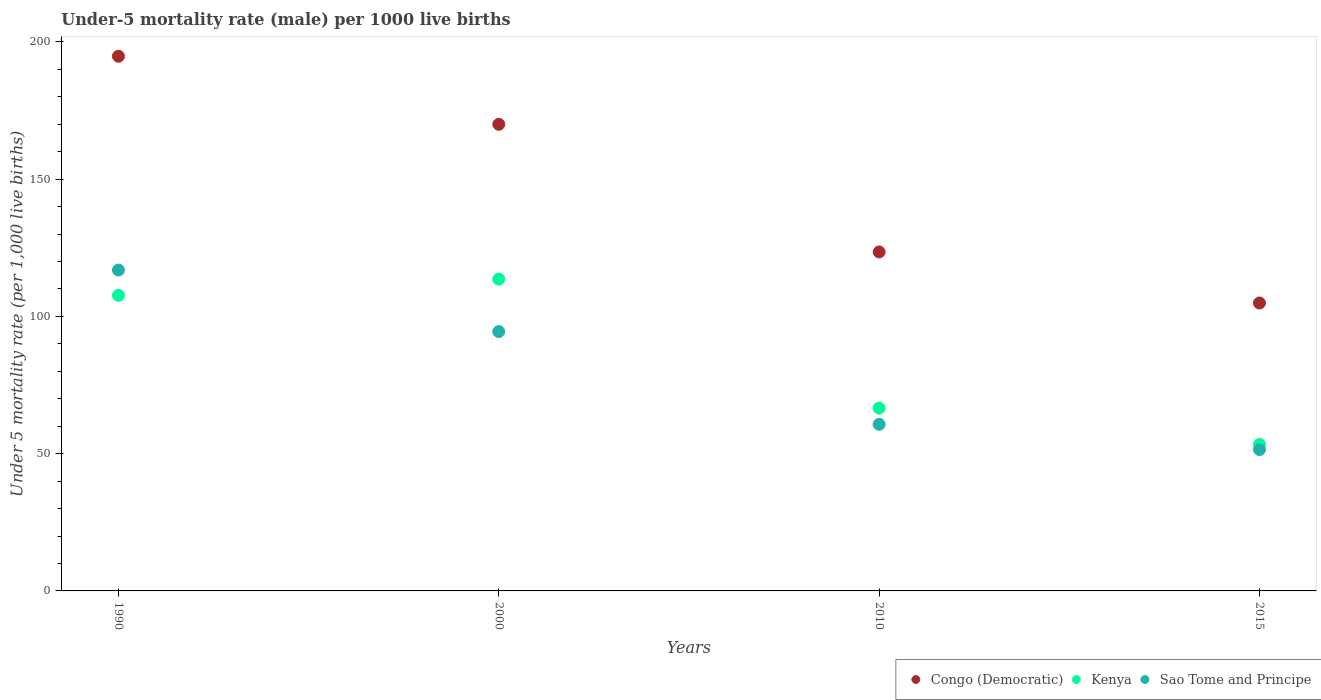How many different coloured dotlines are there?
Ensure brevity in your answer.  3. What is the under-five mortality rate in Kenya in 2000?
Offer a terse response. 113.6. Across all years, what is the maximum under-five mortality rate in Kenya?
Make the answer very short. 113.6. Across all years, what is the minimum under-five mortality rate in Sao Tome and Principe?
Your response must be concise. 51.5. In which year was the under-five mortality rate in Congo (Democratic) minimum?
Provide a succinct answer. 2015. What is the total under-five mortality rate in Kenya in the graph?
Give a very brief answer. 341.3. What is the difference between the under-five mortality rate in Kenya in 2000 and that in 2010?
Offer a terse response. 47. What is the difference between the under-five mortality rate in Sao Tome and Principe in 2015 and the under-five mortality rate in Congo (Democratic) in 2000?
Offer a terse response. -118.5. What is the average under-five mortality rate in Sao Tome and Principe per year?
Ensure brevity in your answer.  80.9. In the year 2010, what is the difference between the under-five mortality rate in Kenya and under-five mortality rate in Congo (Democratic)?
Offer a very short reply. -56.9. What is the ratio of the under-five mortality rate in Sao Tome and Principe in 2000 to that in 2010?
Your response must be concise. 1.56. Is the under-five mortality rate in Sao Tome and Principe in 2000 less than that in 2015?
Make the answer very short. No. What is the difference between the highest and the second highest under-five mortality rate in Sao Tome and Principe?
Your response must be concise. 22.4. What is the difference between the highest and the lowest under-five mortality rate in Congo (Democratic)?
Your answer should be very brief. 89.9. In how many years, is the under-five mortality rate in Congo (Democratic) greater than the average under-five mortality rate in Congo (Democratic) taken over all years?
Provide a succinct answer. 2. Is the sum of the under-five mortality rate in Congo (Democratic) in 1990 and 2010 greater than the maximum under-five mortality rate in Sao Tome and Principe across all years?
Make the answer very short. Yes. Does the under-five mortality rate in Sao Tome and Principe monotonically increase over the years?
Offer a terse response. No. Is the under-five mortality rate in Kenya strictly less than the under-five mortality rate in Congo (Democratic) over the years?
Make the answer very short. Yes. How many dotlines are there?
Ensure brevity in your answer.  3. Does the graph contain any zero values?
Offer a terse response. No. Does the graph contain grids?
Make the answer very short. No. How many legend labels are there?
Make the answer very short. 3. What is the title of the graph?
Give a very brief answer. Under-5 mortality rate (male) per 1000 live births. What is the label or title of the X-axis?
Your answer should be compact. Years. What is the label or title of the Y-axis?
Your response must be concise. Under 5 mortality rate (per 1,0 live births). What is the Under 5 mortality rate (per 1,000 live births) in Congo (Democratic) in 1990?
Provide a succinct answer. 194.8. What is the Under 5 mortality rate (per 1,000 live births) of Kenya in 1990?
Your response must be concise. 107.7. What is the Under 5 mortality rate (per 1,000 live births) of Sao Tome and Principe in 1990?
Provide a succinct answer. 116.9. What is the Under 5 mortality rate (per 1,000 live births) in Congo (Democratic) in 2000?
Your answer should be very brief. 170. What is the Under 5 mortality rate (per 1,000 live births) in Kenya in 2000?
Your response must be concise. 113.6. What is the Under 5 mortality rate (per 1,000 live births) in Sao Tome and Principe in 2000?
Keep it short and to the point. 94.5. What is the Under 5 mortality rate (per 1,000 live births) in Congo (Democratic) in 2010?
Your response must be concise. 123.5. What is the Under 5 mortality rate (per 1,000 live births) in Kenya in 2010?
Provide a short and direct response. 66.6. What is the Under 5 mortality rate (per 1,000 live births) in Sao Tome and Principe in 2010?
Your answer should be compact. 60.7. What is the Under 5 mortality rate (per 1,000 live births) of Congo (Democratic) in 2015?
Make the answer very short. 104.9. What is the Under 5 mortality rate (per 1,000 live births) in Kenya in 2015?
Offer a terse response. 53.4. What is the Under 5 mortality rate (per 1,000 live births) of Sao Tome and Principe in 2015?
Give a very brief answer. 51.5. Across all years, what is the maximum Under 5 mortality rate (per 1,000 live births) of Congo (Democratic)?
Offer a terse response. 194.8. Across all years, what is the maximum Under 5 mortality rate (per 1,000 live births) in Kenya?
Provide a succinct answer. 113.6. Across all years, what is the maximum Under 5 mortality rate (per 1,000 live births) in Sao Tome and Principe?
Offer a terse response. 116.9. Across all years, what is the minimum Under 5 mortality rate (per 1,000 live births) in Congo (Democratic)?
Your answer should be very brief. 104.9. Across all years, what is the minimum Under 5 mortality rate (per 1,000 live births) of Kenya?
Give a very brief answer. 53.4. Across all years, what is the minimum Under 5 mortality rate (per 1,000 live births) of Sao Tome and Principe?
Your answer should be compact. 51.5. What is the total Under 5 mortality rate (per 1,000 live births) in Congo (Democratic) in the graph?
Provide a succinct answer. 593.2. What is the total Under 5 mortality rate (per 1,000 live births) in Kenya in the graph?
Offer a very short reply. 341.3. What is the total Under 5 mortality rate (per 1,000 live births) in Sao Tome and Principe in the graph?
Your answer should be compact. 323.6. What is the difference between the Under 5 mortality rate (per 1,000 live births) in Congo (Democratic) in 1990 and that in 2000?
Make the answer very short. 24.8. What is the difference between the Under 5 mortality rate (per 1,000 live births) of Kenya in 1990 and that in 2000?
Your answer should be compact. -5.9. What is the difference between the Under 5 mortality rate (per 1,000 live births) in Sao Tome and Principe in 1990 and that in 2000?
Keep it short and to the point. 22.4. What is the difference between the Under 5 mortality rate (per 1,000 live births) in Congo (Democratic) in 1990 and that in 2010?
Ensure brevity in your answer.  71.3. What is the difference between the Under 5 mortality rate (per 1,000 live births) of Kenya in 1990 and that in 2010?
Your response must be concise. 41.1. What is the difference between the Under 5 mortality rate (per 1,000 live births) in Sao Tome and Principe in 1990 and that in 2010?
Keep it short and to the point. 56.2. What is the difference between the Under 5 mortality rate (per 1,000 live births) in Congo (Democratic) in 1990 and that in 2015?
Give a very brief answer. 89.9. What is the difference between the Under 5 mortality rate (per 1,000 live births) of Kenya in 1990 and that in 2015?
Offer a terse response. 54.3. What is the difference between the Under 5 mortality rate (per 1,000 live births) in Sao Tome and Principe in 1990 and that in 2015?
Your response must be concise. 65.4. What is the difference between the Under 5 mortality rate (per 1,000 live births) of Congo (Democratic) in 2000 and that in 2010?
Ensure brevity in your answer.  46.5. What is the difference between the Under 5 mortality rate (per 1,000 live births) of Kenya in 2000 and that in 2010?
Offer a terse response. 47. What is the difference between the Under 5 mortality rate (per 1,000 live births) of Sao Tome and Principe in 2000 and that in 2010?
Offer a terse response. 33.8. What is the difference between the Under 5 mortality rate (per 1,000 live births) in Congo (Democratic) in 2000 and that in 2015?
Make the answer very short. 65.1. What is the difference between the Under 5 mortality rate (per 1,000 live births) of Kenya in 2000 and that in 2015?
Give a very brief answer. 60.2. What is the difference between the Under 5 mortality rate (per 1,000 live births) of Sao Tome and Principe in 2010 and that in 2015?
Your response must be concise. 9.2. What is the difference between the Under 5 mortality rate (per 1,000 live births) of Congo (Democratic) in 1990 and the Under 5 mortality rate (per 1,000 live births) of Kenya in 2000?
Give a very brief answer. 81.2. What is the difference between the Under 5 mortality rate (per 1,000 live births) of Congo (Democratic) in 1990 and the Under 5 mortality rate (per 1,000 live births) of Sao Tome and Principe in 2000?
Your answer should be very brief. 100.3. What is the difference between the Under 5 mortality rate (per 1,000 live births) in Kenya in 1990 and the Under 5 mortality rate (per 1,000 live births) in Sao Tome and Principe in 2000?
Offer a very short reply. 13.2. What is the difference between the Under 5 mortality rate (per 1,000 live births) of Congo (Democratic) in 1990 and the Under 5 mortality rate (per 1,000 live births) of Kenya in 2010?
Ensure brevity in your answer.  128.2. What is the difference between the Under 5 mortality rate (per 1,000 live births) of Congo (Democratic) in 1990 and the Under 5 mortality rate (per 1,000 live births) of Sao Tome and Principe in 2010?
Your answer should be compact. 134.1. What is the difference between the Under 5 mortality rate (per 1,000 live births) of Congo (Democratic) in 1990 and the Under 5 mortality rate (per 1,000 live births) of Kenya in 2015?
Your answer should be compact. 141.4. What is the difference between the Under 5 mortality rate (per 1,000 live births) of Congo (Democratic) in 1990 and the Under 5 mortality rate (per 1,000 live births) of Sao Tome and Principe in 2015?
Offer a very short reply. 143.3. What is the difference between the Under 5 mortality rate (per 1,000 live births) of Kenya in 1990 and the Under 5 mortality rate (per 1,000 live births) of Sao Tome and Principe in 2015?
Your answer should be compact. 56.2. What is the difference between the Under 5 mortality rate (per 1,000 live births) in Congo (Democratic) in 2000 and the Under 5 mortality rate (per 1,000 live births) in Kenya in 2010?
Keep it short and to the point. 103.4. What is the difference between the Under 5 mortality rate (per 1,000 live births) in Congo (Democratic) in 2000 and the Under 5 mortality rate (per 1,000 live births) in Sao Tome and Principe in 2010?
Provide a succinct answer. 109.3. What is the difference between the Under 5 mortality rate (per 1,000 live births) in Kenya in 2000 and the Under 5 mortality rate (per 1,000 live births) in Sao Tome and Principe in 2010?
Offer a very short reply. 52.9. What is the difference between the Under 5 mortality rate (per 1,000 live births) in Congo (Democratic) in 2000 and the Under 5 mortality rate (per 1,000 live births) in Kenya in 2015?
Provide a short and direct response. 116.6. What is the difference between the Under 5 mortality rate (per 1,000 live births) in Congo (Democratic) in 2000 and the Under 5 mortality rate (per 1,000 live births) in Sao Tome and Principe in 2015?
Your answer should be very brief. 118.5. What is the difference between the Under 5 mortality rate (per 1,000 live births) in Kenya in 2000 and the Under 5 mortality rate (per 1,000 live births) in Sao Tome and Principe in 2015?
Offer a terse response. 62.1. What is the difference between the Under 5 mortality rate (per 1,000 live births) of Congo (Democratic) in 2010 and the Under 5 mortality rate (per 1,000 live births) of Kenya in 2015?
Provide a short and direct response. 70.1. What is the difference between the Under 5 mortality rate (per 1,000 live births) of Congo (Democratic) in 2010 and the Under 5 mortality rate (per 1,000 live births) of Sao Tome and Principe in 2015?
Keep it short and to the point. 72. What is the average Under 5 mortality rate (per 1,000 live births) in Congo (Democratic) per year?
Give a very brief answer. 148.3. What is the average Under 5 mortality rate (per 1,000 live births) of Kenya per year?
Provide a short and direct response. 85.33. What is the average Under 5 mortality rate (per 1,000 live births) of Sao Tome and Principe per year?
Your answer should be very brief. 80.9. In the year 1990, what is the difference between the Under 5 mortality rate (per 1,000 live births) in Congo (Democratic) and Under 5 mortality rate (per 1,000 live births) in Kenya?
Offer a very short reply. 87.1. In the year 1990, what is the difference between the Under 5 mortality rate (per 1,000 live births) in Congo (Democratic) and Under 5 mortality rate (per 1,000 live births) in Sao Tome and Principe?
Your answer should be very brief. 77.9. In the year 2000, what is the difference between the Under 5 mortality rate (per 1,000 live births) of Congo (Democratic) and Under 5 mortality rate (per 1,000 live births) of Kenya?
Provide a succinct answer. 56.4. In the year 2000, what is the difference between the Under 5 mortality rate (per 1,000 live births) in Congo (Democratic) and Under 5 mortality rate (per 1,000 live births) in Sao Tome and Principe?
Keep it short and to the point. 75.5. In the year 2010, what is the difference between the Under 5 mortality rate (per 1,000 live births) in Congo (Democratic) and Under 5 mortality rate (per 1,000 live births) in Kenya?
Offer a very short reply. 56.9. In the year 2010, what is the difference between the Under 5 mortality rate (per 1,000 live births) in Congo (Democratic) and Under 5 mortality rate (per 1,000 live births) in Sao Tome and Principe?
Give a very brief answer. 62.8. In the year 2010, what is the difference between the Under 5 mortality rate (per 1,000 live births) in Kenya and Under 5 mortality rate (per 1,000 live births) in Sao Tome and Principe?
Your response must be concise. 5.9. In the year 2015, what is the difference between the Under 5 mortality rate (per 1,000 live births) in Congo (Democratic) and Under 5 mortality rate (per 1,000 live births) in Kenya?
Make the answer very short. 51.5. In the year 2015, what is the difference between the Under 5 mortality rate (per 1,000 live births) in Congo (Democratic) and Under 5 mortality rate (per 1,000 live births) in Sao Tome and Principe?
Provide a succinct answer. 53.4. What is the ratio of the Under 5 mortality rate (per 1,000 live births) of Congo (Democratic) in 1990 to that in 2000?
Offer a very short reply. 1.15. What is the ratio of the Under 5 mortality rate (per 1,000 live births) in Kenya in 1990 to that in 2000?
Offer a terse response. 0.95. What is the ratio of the Under 5 mortality rate (per 1,000 live births) in Sao Tome and Principe in 1990 to that in 2000?
Make the answer very short. 1.24. What is the ratio of the Under 5 mortality rate (per 1,000 live births) in Congo (Democratic) in 1990 to that in 2010?
Ensure brevity in your answer.  1.58. What is the ratio of the Under 5 mortality rate (per 1,000 live births) in Kenya in 1990 to that in 2010?
Ensure brevity in your answer.  1.62. What is the ratio of the Under 5 mortality rate (per 1,000 live births) in Sao Tome and Principe in 1990 to that in 2010?
Provide a succinct answer. 1.93. What is the ratio of the Under 5 mortality rate (per 1,000 live births) of Congo (Democratic) in 1990 to that in 2015?
Offer a very short reply. 1.86. What is the ratio of the Under 5 mortality rate (per 1,000 live births) in Kenya in 1990 to that in 2015?
Provide a short and direct response. 2.02. What is the ratio of the Under 5 mortality rate (per 1,000 live births) in Sao Tome and Principe in 1990 to that in 2015?
Provide a short and direct response. 2.27. What is the ratio of the Under 5 mortality rate (per 1,000 live births) of Congo (Democratic) in 2000 to that in 2010?
Your answer should be very brief. 1.38. What is the ratio of the Under 5 mortality rate (per 1,000 live births) in Kenya in 2000 to that in 2010?
Provide a succinct answer. 1.71. What is the ratio of the Under 5 mortality rate (per 1,000 live births) in Sao Tome and Principe in 2000 to that in 2010?
Offer a very short reply. 1.56. What is the ratio of the Under 5 mortality rate (per 1,000 live births) in Congo (Democratic) in 2000 to that in 2015?
Keep it short and to the point. 1.62. What is the ratio of the Under 5 mortality rate (per 1,000 live births) of Kenya in 2000 to that in 2015?
Your response must be concise. 2.13. What is the ratio of the Under 5 mortality rate (per 1,000 live births) of Sao Tome and Principe in 2000 to that in 2015?
Offer a very short reply. 1.83. What is the ratio of the Under 5 mortality rate (per 1,000 live births) of Congo (Democratic) in 2010 to that in 2015?
Ensure brevity in your answer.  1.18. What is the ratio of the Under 5 mortality rate (per 1,000 live births) in Kenya in 2010 to that in 2015?
Your answer should be very brief. 1.25. What is the ratio of the Under 5 mortality rate (per 1,000 live births) in Sao Tome and Principe in 2010 to that in 2015?
Your answer should be compact. 1.18. What is the difference between the highest and the second highest Under 5 mortality rate (per 1,000 live births) in Congo (Democratic)?
Your response must be concise. 24.8. What is the difference between the highest and the second highest Under 5 mortality rate (per 1,000 live births) in Sao Tome and Principe?
Your response must be concise. 22.4. What is the difference between the highest and the lowest Under 5 mortality rate (per 1,000 live births) of Congo (Democratic)?
Give a very brief answer. 89.9. What is the difference between the highest and the lowest Under 5 mortality rate (per 1,000 live births) of Kenya?
Give a very brief answer. 60.2. What is the difference between the highest and the lowest Under 5 mortality rate (per 1,000 live births) in Sao Tome and Principe?
Make the answer very short. 65.4. 